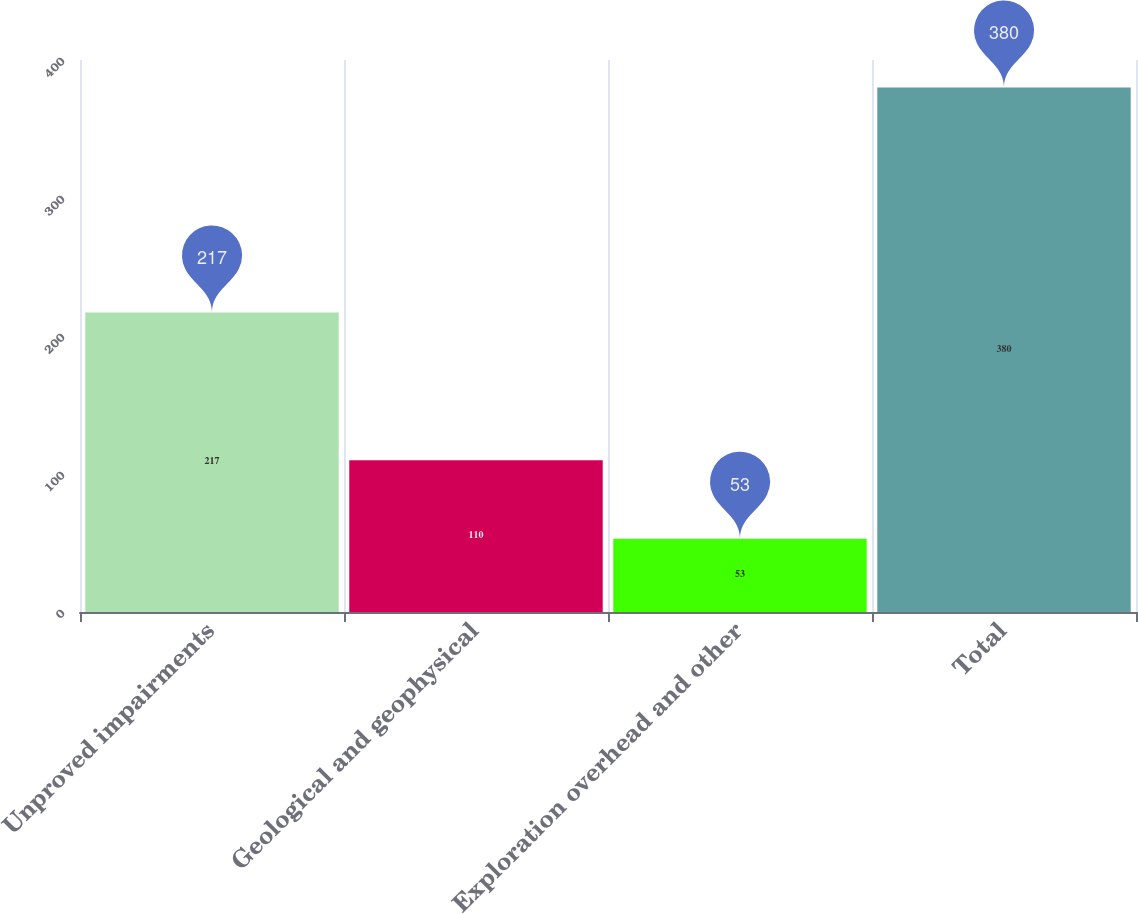Convert chart to OTSL. <chart><loc_0><loc_0><loc_500><loc_500><bar_chart><fcel>Unproved impairments<fcel>Geological and geophysical<fcel>Exploration overhead and other<fcel>Total<nl><fcel>217<fcel>110<fcel>53<fcel>380<nl></chart> 